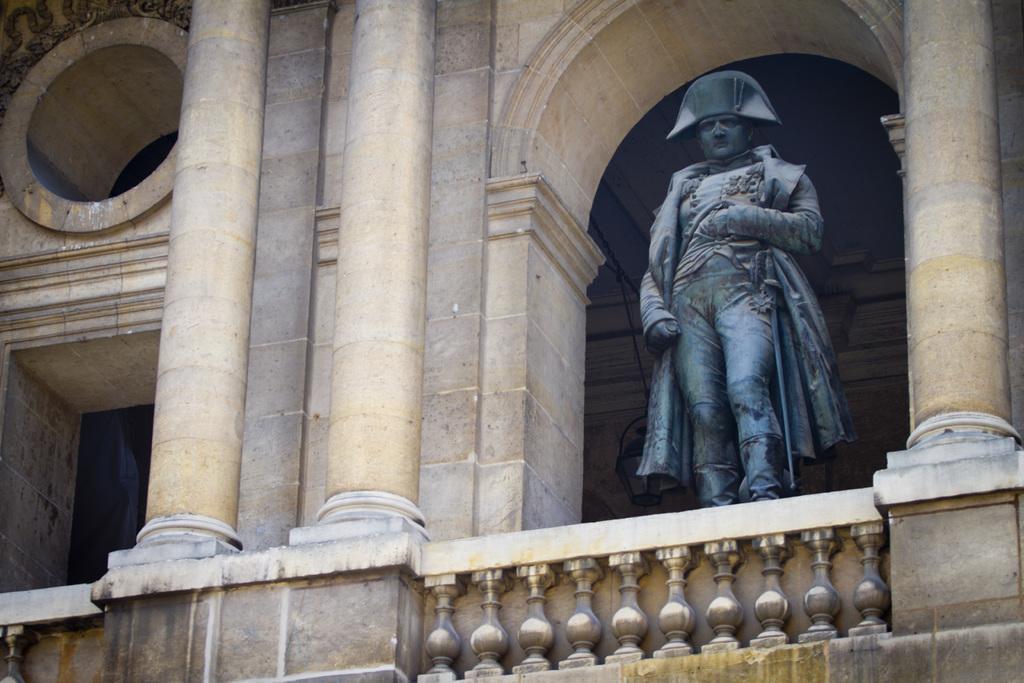Could you give a brief overview of what you see in this image? In this image we can see statue, pillars, wall and grill. 